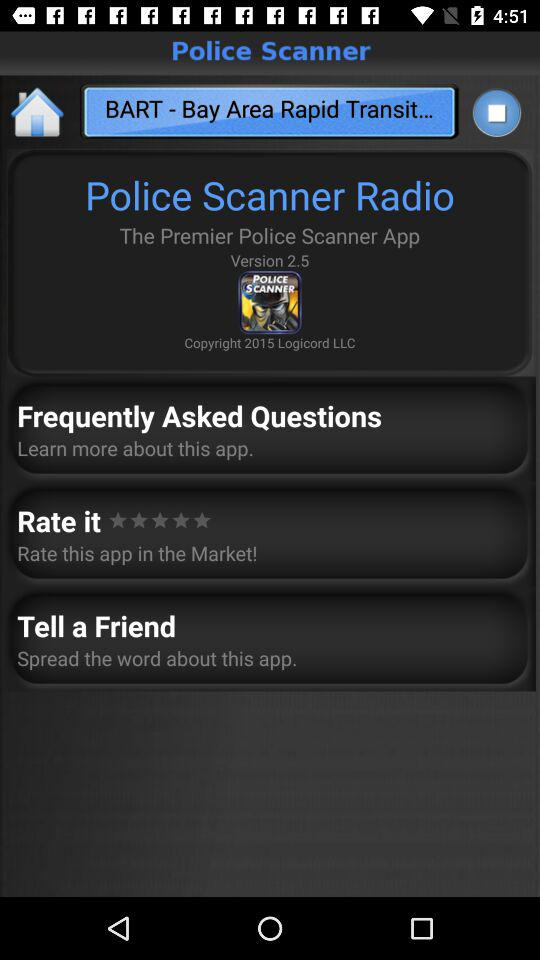What is the version of the application? The version is 2.5. 